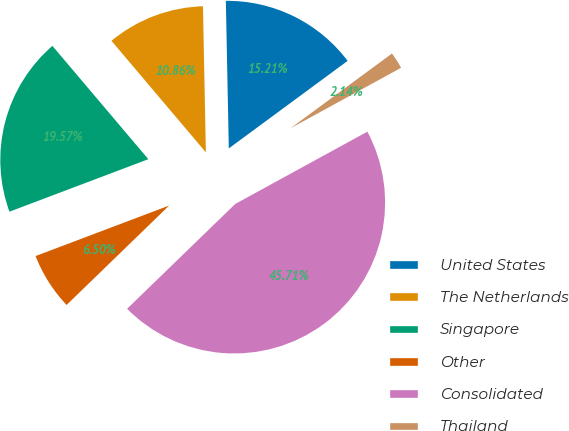Convert chart. <chart><loc_0><loc_0><loc_500><loc_500><pie_chart><fcel>United States<fcel>The Netherlands<fcel>Singapore<fcel>Other<fcel>Consolidated<fcel>Thailand<nl><fcel>15.21%<fcel>10.86%<fcel>19.57%<fcel>6.5%<fcel>45.71%<fcel>2.14%<nl></chart> 